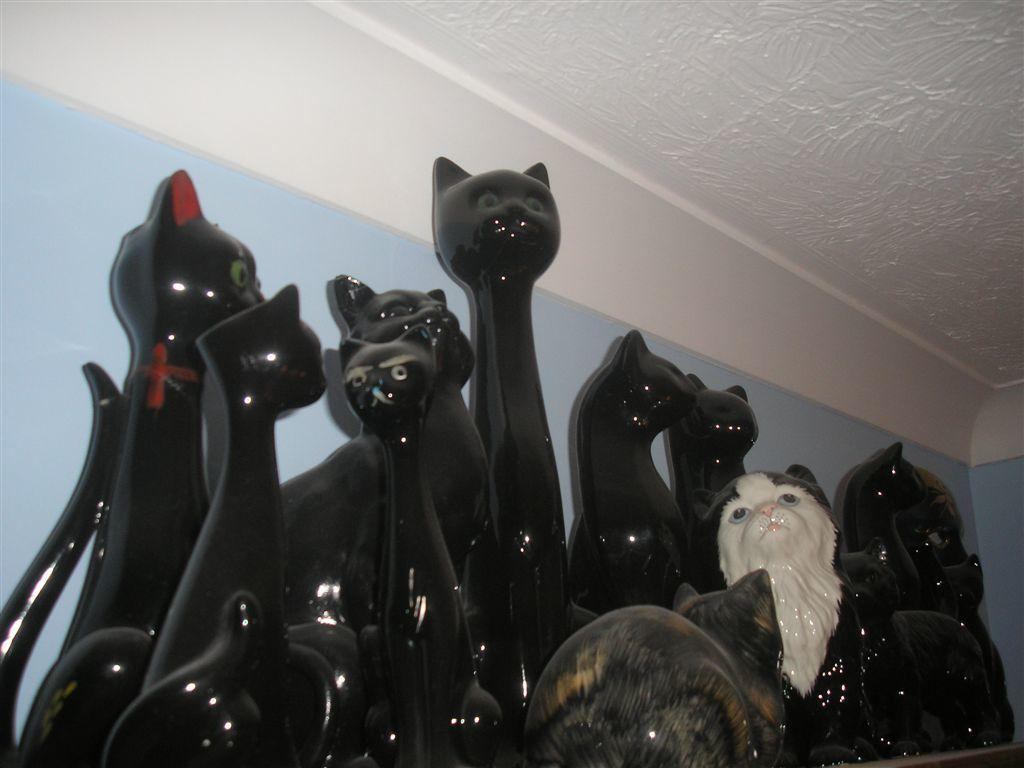What type of animals are depicted in the sculptures in the image? There are sculptured cats in the image. How are the sculptured cats arranged in the image? The sculptured cats are placed in groups. What color are the sculptured cats? The sculptured cats are black in color. What can be seen in the background of the image? There is a wall in the background of the image. What color is the ceiling in the image? The ceiling is white in color. What type of protest is taking place in the image? There is no protest present in the image; it features sculptured cats placed in groups. Can you describe the cave where the sculptured cats are located? There is no cave present in the image; it features a wall in the background and a white ceiling. 